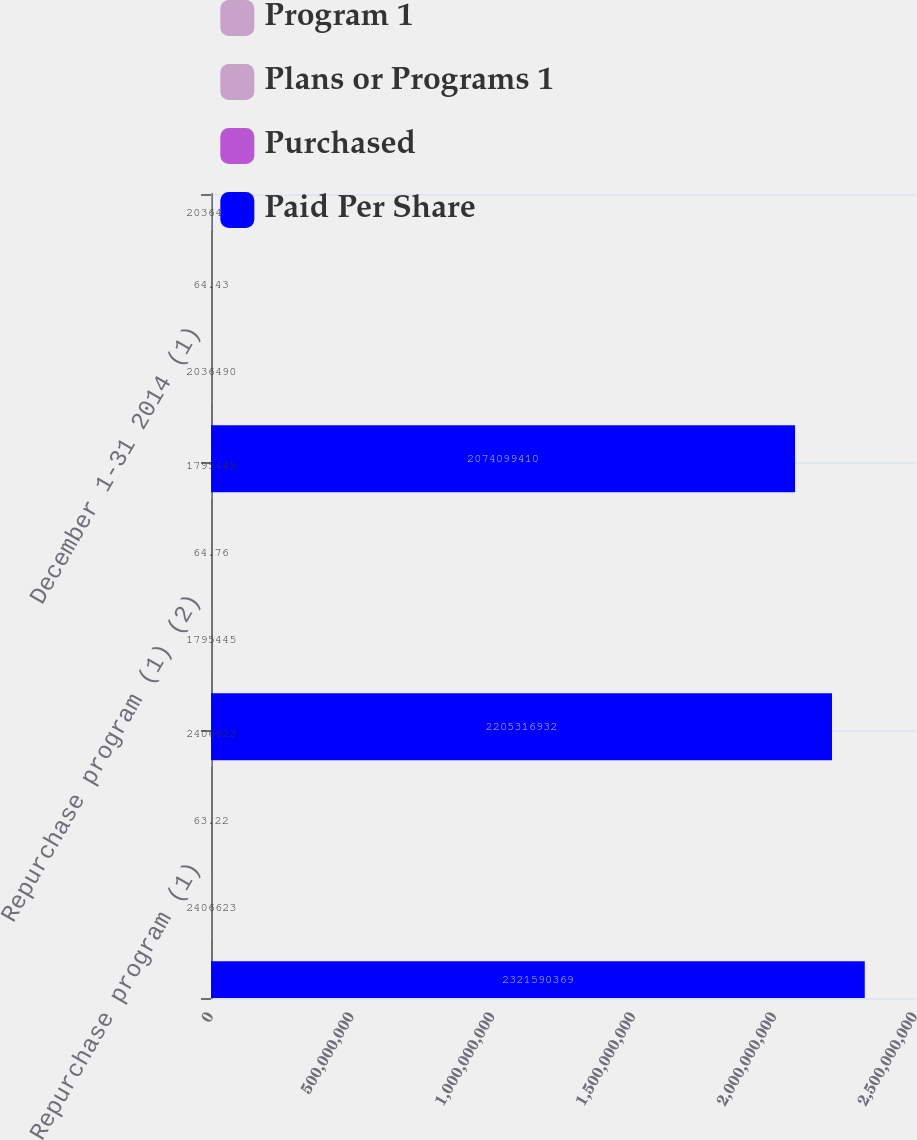Convert chart. <chart><loc_0><loc_0><loc_500><loc_500><stacked_bar_chart><ecel><fcel>Repurchase program (1)<fcel>Repurchase program (1) (2)<fcel>December 1-31 2014 (1)<nl><fcel>Program 1<fcel>2.40662e+06<fcel>1.79544e+06<fcel>2.03649e+06<nl><fcel>Plans or Programs 1<fcel>63.22<fcel>64.76<fcel>64.43<nl><fcel>Purchased<fcel>2.40662e+06<fcel>1.79544e+06<fcel>2.03649e+06<nl><fcel>Paid Per Share<fcel>2.32159e+09<fcel>2.20532e+09<fcel>2.0741e+09<nl></chart> 